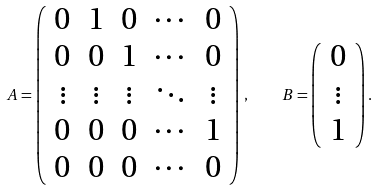<formula> <loc_0><loc_0><loc_500><loc_500>A = \left ( \begin{array} { c c c c c } 0 & 1 & 0 & \cdots & 0 \\ 0 & 0 & 1 & \cdots & 0 \\ \vdots & \vdots & \vdots & \ddots & \vdots \\ 0 & 0 & 0 & \cdots & 1 \\ 0 & 0 & 0 & \cdots & 0 \\ \end{array} \right ) \, , \quad B = \left ( \begin{array} { c } 0 \\ \vdots \\ 1 \end{array} \right ) .</formula> 